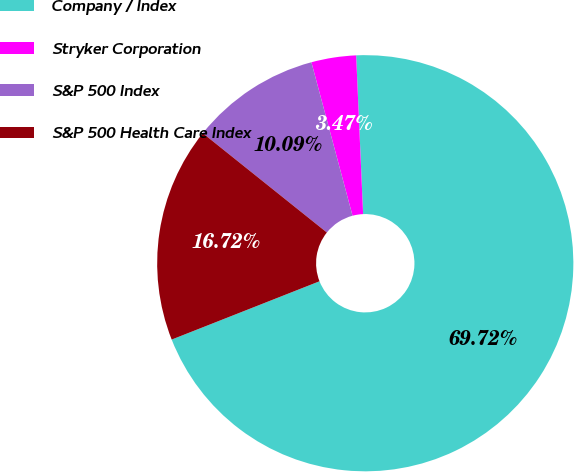Convert chart. <chart><loc_0><loc_0><loc_500><loc_500><pie_chart><fcel>Company / Index<fcel>Stryker Corporation<fcel>S&P 500 Index<fcel>S&P 500 Health Care Index<nl><fcel>69.72%<fcel>3.47%<fcel>10.09%<fcel>16.72%<nl></chart> 